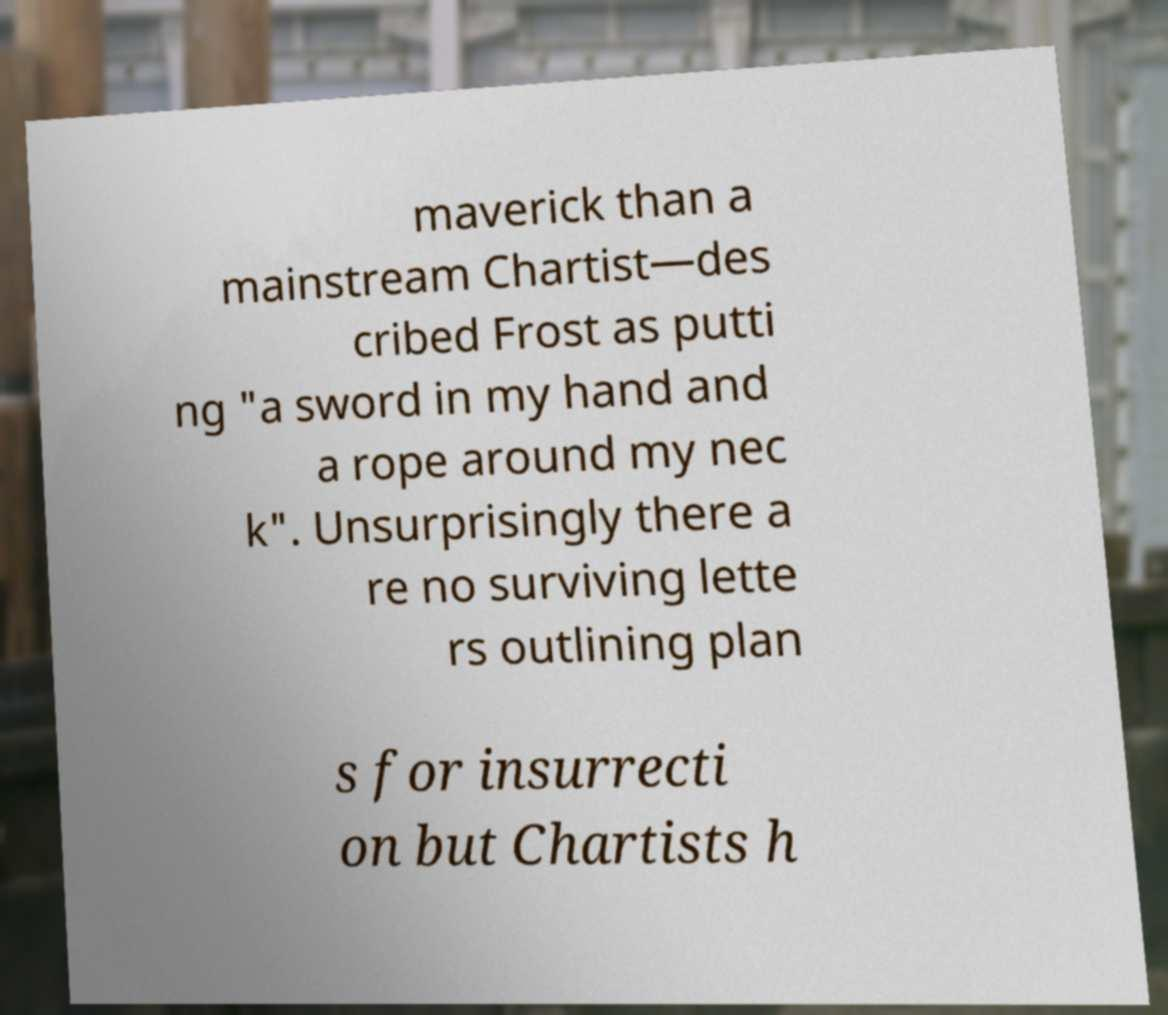What messages or text are displayed in this image? I need them in a readable, typed format. maverick than a mainstream Chartist—des cribed Frost as putti ng "a sword in my hand and a rope around my nec k". Unsurprisingly there a re no surviving lette rs outlining plan s for insurrecti on but Chartists h 